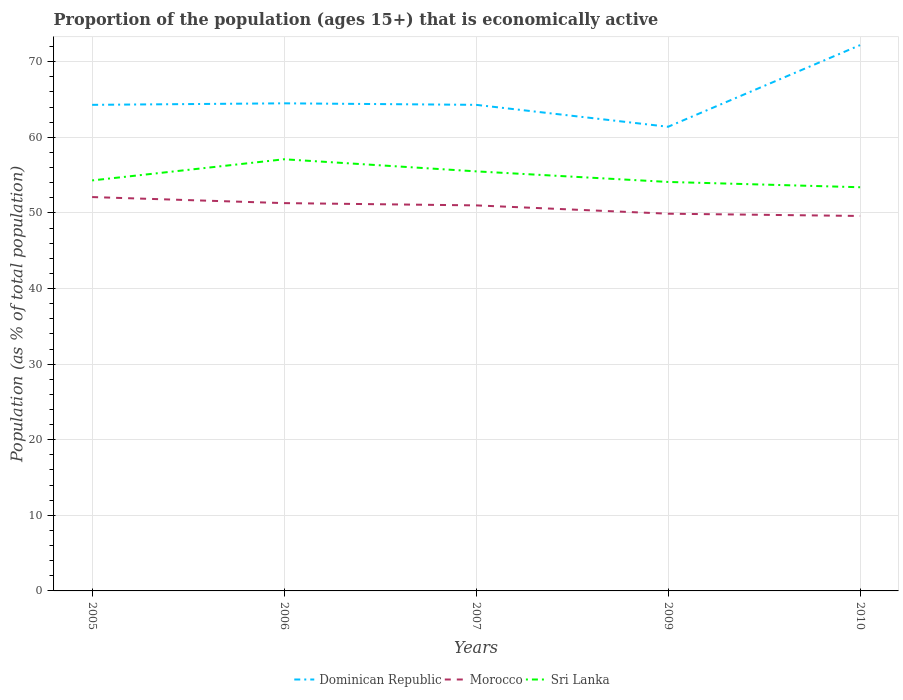Is the number of lines equal to the number of legend labels?
Your answer should be very brief. Yes. Across all years, what is the maximum proportion of the population that is economically active in Sri Lanka?
Your answer should be compact. 53.4. In which year was the proportion of the population that is economically active in Morocco maximum?
Your answer should be very brief. 2010. What is the total proportion of the population that is economically active in Morocco in the graph?
Your response must be concise. 0.3. What is the difference between the highest and the second highest proportion of the population that is economically active in Sri Lanka?
Offer a terse response. 3.7. What is the difference between the highest and the lowest proportion of the population that is economically active in Sri Lanka?
Your answer should be compact. 2. How many lines are there?
Give a very brief answer. 3. Are the values on the major ticks of Y-axis written in scientific E-notation?
Provide a succinct answer. No. Does the graph contain any zero values?
Your answer should be compact. No. How many legend labels are there?
Provide a succinct answer. 3. What is the title of the graph?
Your response must be concise. Proportion of the population (ages 15+) that is economically active. What is the label or title of the Y-axis?
Make the answer very short. Population (as % of total population). What is the Population (as % of total population) of Dominican Republic in 2005?
Offer a very short reply. 64.3. What is the Population (as % of total population) of Morocco in 2005?
Provide a succinct answer. 52.1. What is the Population (as % of total population) in Sri Lanka in 2005?
Ensure brevity in your answer.  54.3. What is the Population (as % of total population) in Dominican Republic in 2006?
Make the answer very short. 64.5. What is the Population (as % of total population) in Morocco in 2006?
Your answer should be very brief. 51.3. What is the Population (as % of total population) in Sri Lanka in 2006?
Keep it short and to the point. 57.1. What is the Population (as % of total population) of Dominican Republic in 2007?
Give a very brief answer. 64.3. What is the Population (as % of total population) in Morocco in 2007?
Your answer should be compact. 51. What is the Population (as % of total population) in Sri Lanka in 2007?
Offer a terse response. 55.5. What is the Population (as % of total population) in Dominican Republic in 2009?
Your answer should be compact. 61.4. What is the Population (as % of total population) of Morocco in 2009?
Your response must be concise. 49.9. What is the Population (as % of total population) in Sri Lanka in 2009?
Your answer should be very brief. 54.1. What is the Population (as % of total population) of Dominican Republic in 2010?
Your answer should be compact. 72.2. What is the Population (as % of total population) of Morocco in 2010?
Provide a succinct answer. 49.6. What is the Population (as % of total population) in Sri Lanka in 2010?
Offer a terse response. 53.4. Across all years, what is the maximum Population (as % of total population) of Dominican Republic?
Your answer should be compact. 72.2. Across all years, what is the maximum Population (as % of total population) of Morocco?
Offer a very short reply. 52.1. Across all years, what is the maximum Population (as % of total population) of Sri Lanka?
Offer a terse response. 57.1. Across all years, what is the minimum Population (as % of total population) in Dominican Republic?
Your response must be concise. 61.4. Across all years, what is the minimum Population (as % of total population) of Morocco?
Offer a very short reply. 49.6. Across all years, what is the minimum Population (as % of total population) in Sri Lanka?
Give a very brief answer. 53.4. What is the total Population (as % of total population) of Dominican Republic in the graph?
Ensure brevity in your answer.  326.7. What is the total Population (as % of total population) of Morocco in the graph?
Offer a terse response. 253.9. What is the total Population (as % of total population) in Sri Lanka in the graph?
Your response must be concise. 274.4. What is the difference between the Population (as % of total population) in Dominican Republic in 2005 and that in 2006?
Your answer should be compact. -0.2. What is the difference between the Population (as % of total population) in Dominican Republic in 2005 and that in 2007?
Give a very brief answer. 0. What is the difference between the Population (as % of total population) of Morocco in 2005 and that in 2007?
Give a very brief answer. 1.1. What is the difference between the Population (as % of total population) of Sri Lanka in 2005 and that in 2009?
Ensure brevity in your answer.  0.2. What is the difference between the Population (as % of total population) of Dominican Republic in 2005 and that in 2010?
Provide a succinct answer. -7.9. What is the difference between the Population (as % of total population) of Morocco in 2006 and that in 2007?
Your response must be concise. 0.3. What is the difference between the Population (as % of total population) of Sri Lanka in 2006 and that in 2007?
Provide a succinct answer. 1.6. What is the difference between the Population (as % of total population) of Dominican Republic in 2006 and that in 2009?
Offer a very short reply. 3.1. What is the difference between the Population (as % of total population) of Morocco in 2006 and that in 2009?
Ensure brevity in your answer.  1.4. What is the difference between the Population (as % of total population) of Dominican Republic in 2006 and that in 2010?
Make the answer very short. -7.7. What is the difference between the Population (as % of total population) in Sri Lanka in 2006 and that in 2010?
Give a very brief answer. 3.7. What is the difference between the Population (as % of total population) of Dominican Republic in 2007 and that in 2009?
Your response must be concise. 2.9. What is the difference between the Population (as % of total population) in Morocco in 2007 and that in 2009?
Your answer should be compact. 1.1. What is the difference between the Population (as % of total population) of Sri Lanka in 2007 and that in 2009?
Offer a terse response. 1.4. What is the difference between the Population (as % of total population) in Dominican Republic in 2007 and that in 2010?
Offer a terse response. -7.9. What is the difference between the Population (as % of total population) in Dominican Republic in 2005 and the Population (as % of total population) in Morocco in 2006?
Your answer should be very brief. 13. What is the difference between the Population (as % of total population) of Dominican Republic in 2005 and the Population (as % of total population) of Sri Lanka in 2006?
Make the answer very short. 7.2. What is the difference between the Population (as % of total population) of Morocco in 2005 and the Population (as % of total population) of Sri Lanka in 2006?
Give a very brief answer. -5. What is the difference between the Population (as % of total population) of Dominican Republic in 2005 and the Population (as % of total population) of Sri Lanka in 2007?
Ensure brevity in your answer.  8.8. What is the difference between the Population (as % of total population) in Morocco in 2005 and the Population (as % of total population) in Sri Lanka in 2007?
Make the answer very short. -3.4. What is the difference between the Population (as % of total population) in Dominican Republic in 2005 and the Population (as % of total population) in Morocco in 2009?
Make the answer very short. 14.4. What is the difference between the Population (as % of total population) of Dominican Republic in 2005 and the Population (as % of total population) of Sri Lanka in 2009?
Provide a short and direct response. 10.2. What is the difference between the Population (as % of total population) of Dominican Republic in 2005 and the Population (as % of total population) of Morocco in 2010?
Offer a very short reply. 14.7. What is the difference between the Population (as % of total population) in Dominican Republic in 2005 and the Population (as % of total population) in Sri Lanka in 2010?
Your answer should be compact. 10.9. What is the difference between the Population (as % of total population) in Dominican Republic in 2006 and the Population (as % of total population) in Morocco in 2007?
Your answer should be very brief. 13.5. What is the difference between the Population (as % of total population) of Dominican Republic in 2006 and the Population (as % of total population) of Sri Lanka in 2007?
Provide a short and direct response. 9. What is the difference between the Population (as % of total population) in Dominican Republic in 2006 and the Population (as % of total population) in Sri Lanka in 2010?
Make the answer very short. 11.1. What is the difference between the Population (as % of total population) in Morocco in 2006 and the Population (as % of total population) in Sri Lanka in 2010?
Offer a terse response. -2.1. What is the difference between the Population (as % of total population) of Dominican Republic in 2007 and the Population (as % of total population) of Morocco in 2009?
Keep it short and to the point. 14.4. What is the difference between the Population (as % of total population) of Morocco in 2007 and the Population (as % of total population) of Sri Lanka in 2009?
Give a very brief answer. -3.1. What is the difference between the Population (as % of total population) in Dominican Republic in 2007 and the Population (as % of total population) in Morocco in 2010?
Give a very brief answer. 14.7. What is the difference between the Population (as % of total population) of Morocco in 2007 and the Population (as % of total population) of Sri Lanka in 2010?
Provide a short and direct response. -2.4. What is the difference between the Population (as % of total population) of Dominican Republic in 2009 and the Population (as % of total population) of Morocco in 2010?
Offer a very short reply. 11.8. What is the difference between the Population (as % of total population) of Morocco in 2009 and the Population (as % of total population) of Sri Lanka in 2010?
Provide a short and direct response. -3.5. What is the average Population (as % of total population) of Dominican Republic per year?
Give a very brief answer. 65.34. What is the average Population (as % of total population) in Morocco per year?
Provide a succinct answer. 50.78. What is the average Population (as % of total population) of Sri Lanka per year?
Give a very brief answer. 54.88. In the year 2005, what is the difference between the Population (as % of total population) in Dominican Republic and Population (as % of total population) in Morocco?
Provide a short and direct response. 12.2. In the year 2005, what is the difference between the Population (as % of total population) in Morocco and Population (as % of total population) in Sri Lanka?
Ensure brevity in your answer.  -2.2. In the year 2006, what is the difference between the Population (as % of total population) in Dominican Republic and Population (as % of total population) in Morocco?
Ensure brevity in your answer.  13.2. In the year 2006, what is the difference between the Population (as % of total population) of Dominican Republic and Population (as % of total population) of Sri Lanka?
Provide a succinct answer. 7.4. In the year 2007, what is the difference between the Population (as % of total population) of Morocco and Population (as % of total population) of Sri Lanka?
Your answer should be very brief. -4.5. In the year 2009, what is the difference between the Population (as % of total population) of Dominican Republic and Population (as % of total population) of Morocco?
Give a very brief answer. 11.5. In the year 2009, what is the difference between the Population (as % of total population) of Dominican Republic and Population (as % of total population) of Sri Lanka?
Ensure brevity in your answer.  7.3. In the year 2010, what is the difference between the Population (as % of total population) in Dominican Republic and Population (as % of total population) in Morocco?
Offer a terse response. 22.6. What is the ratio of the Population (as % of total population) of Morocco in 2005 to that in 2006?
Provide a succinct answer. 1.02. What is the ratio of the Population (as % of total population) in Sri Lanka in 2005 to that in 2006?
Your response must be concise. 0.95. What is the ratio of the Population (as % of total population) of Dominican Republic in 2005 to that in 2007?
Offer a terse response. 1. What is the ratio of the Population (as % of total population) in Morocco in 2005 to that in 2007?
Offer a very short reply. 1.02. What is the ratio of the Population (as % of total population) in Sri Lanka in 2005 to that in 2007?
Provide a short and direct response. 0.98. What is the ratio of the Population (as % of total population) of Dominican Republic in 2005 to that in 2009?
Keep it short and to the point. 1.05. What is the ratio of the Population (as % of total population) in Morocco in 2005 to that in 2009?
Offer a terse response. 1.04. What is the ratio of the Population (as % of total population) of Sri Lanka in 2005 to that in 2009?
Offer a very short reply. 1. What is the ratio of the Population (as % of total population) in Dominican Republic in 2005 to that in 2010?
Your answer should be very brief. 0.89. What is the ratio of the Population (as % of total population) of Morocco in 2005 to that in 2010?
Ensure brevity in your answer.  1.05. What is the ratio of the Population (as % of total population) of Sri Lanka in 2005 to that in 2010?
Provide a short and direct response. 1.02. What is the ratio of the Population (as % of total population) in Dominican Republic in 2006 to that in 2007?
Your answer should be very brief. 1. What is the ratio of the Population (as % of total population) in Morocco in 2006 to that in 2007?
Provide a short and direct response. 1.01. What is the ratio of the Population (as % of total population) of Sri Lanka in 2006 to that in 2007?
Ensure brevity in your answer.  1.03. What is the ratio of the Population (as % of total population) in Dominican Republic in 2006 to that in 2009?
Make the answer very short. 1.05. What is the ratio of the Population (as % of total population) in Morocco in 2006 to that in 2009?
Your answer should be compact. 1.03. What is the ratio of the Population (as % of total population) in Sri Lanka in 2006 to that in 2009?
Give a very brief answer. 1.06. What is the ratio of the Population (as % of total population) in Dominican Republic in 2006 to that in 2010?
Your response must be concise. 0.89. What is the ratio of the Population (as % of total population) in Morocco in 2006 to that in 2010?
Make the answer very short. 1.03. What is the ratio of the Population (as % of total population) in Sri Lanka in 2006 to that in 2010?
Your answer should be compact. 1.07. What is the ratio of the Population (as % of total population) in Dominican Republic in 2007 to that in 2009?
Provide a succinct answer. 1.05. What is the ratio of the Population (as % of total population) of Sri Lanka in 2007 to that in 2009?
Provide a short and direct response. 1.03. What is the ratio of the Population (as % of total population) in Dominican Republic in 2007 to that in 2010?
Provide a succinct answer. 0.89. What is the ratio of the Population (as % of total population) in Morocco in 2007 to that in 2010?
Ensure brevity in your answer.  1.03. What is the ratio of the Population (as % of total population) of Sri Lanka in 2007 to that in 2010?
Provide a short and direct response. 1.04. What is the ratio of the Population (as % of total population) in Dominican Republic in 2009 to that in 2010?
Provide a short and direct response. 0.85. What is the ratio of the Population (as % of total population) of Morocco in 2009 to that in 2010?
Offer a very short reply. 1.01. What is the ratio of the Population (as % of total population) in Sri Lanka in 2009 to that in 2010?
Your answer should be compact. 1.01. What is the difference between the highest and the second highest Population (as % of total population) of Dominican Republic?
Keep it short and to the point. 7.7. What is the difference between the highest and the lowest Population (as % of total population) of Morocco?
Your answer should be compact. 2.5. What is the difference between the highest and the lowest Population (as % of total population) in Sri Lanka?
Give a very brief answer. 3.7. 